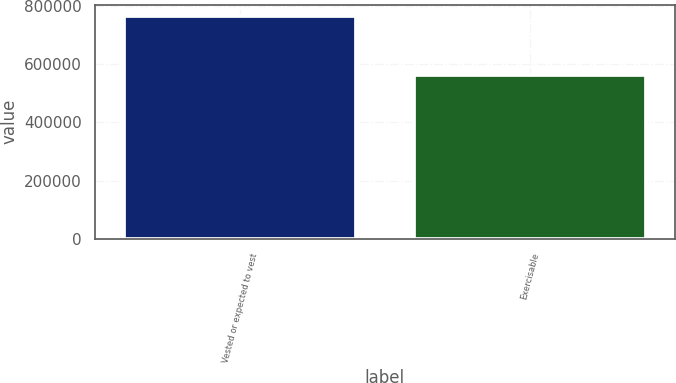Convert chart to OTSL. <chart><loc_0><loc_0><loc_500><loc_500><bar_chart><fcel>Vested or expected to vest<fcel>Exercisable<nl><fcel>766430<fcel>561844<nl></chart> 